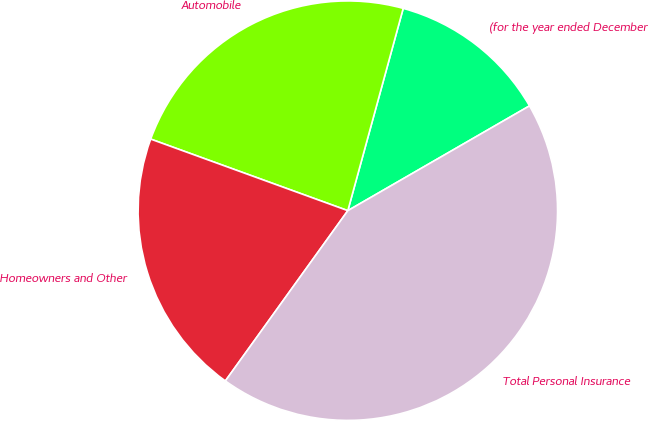Convert chart. <chart><loc_0><loc_0><loc_500><loc_500><pie_chart><fcel>(for the year ended December<fcel>Automobile<fcel>Homeowners and Other<fcel>Total Personal Insurance<nl><fcel>12.42%<fcel>23.71%<fcel>20.62%<fcel>43.25%<nl></chart> 